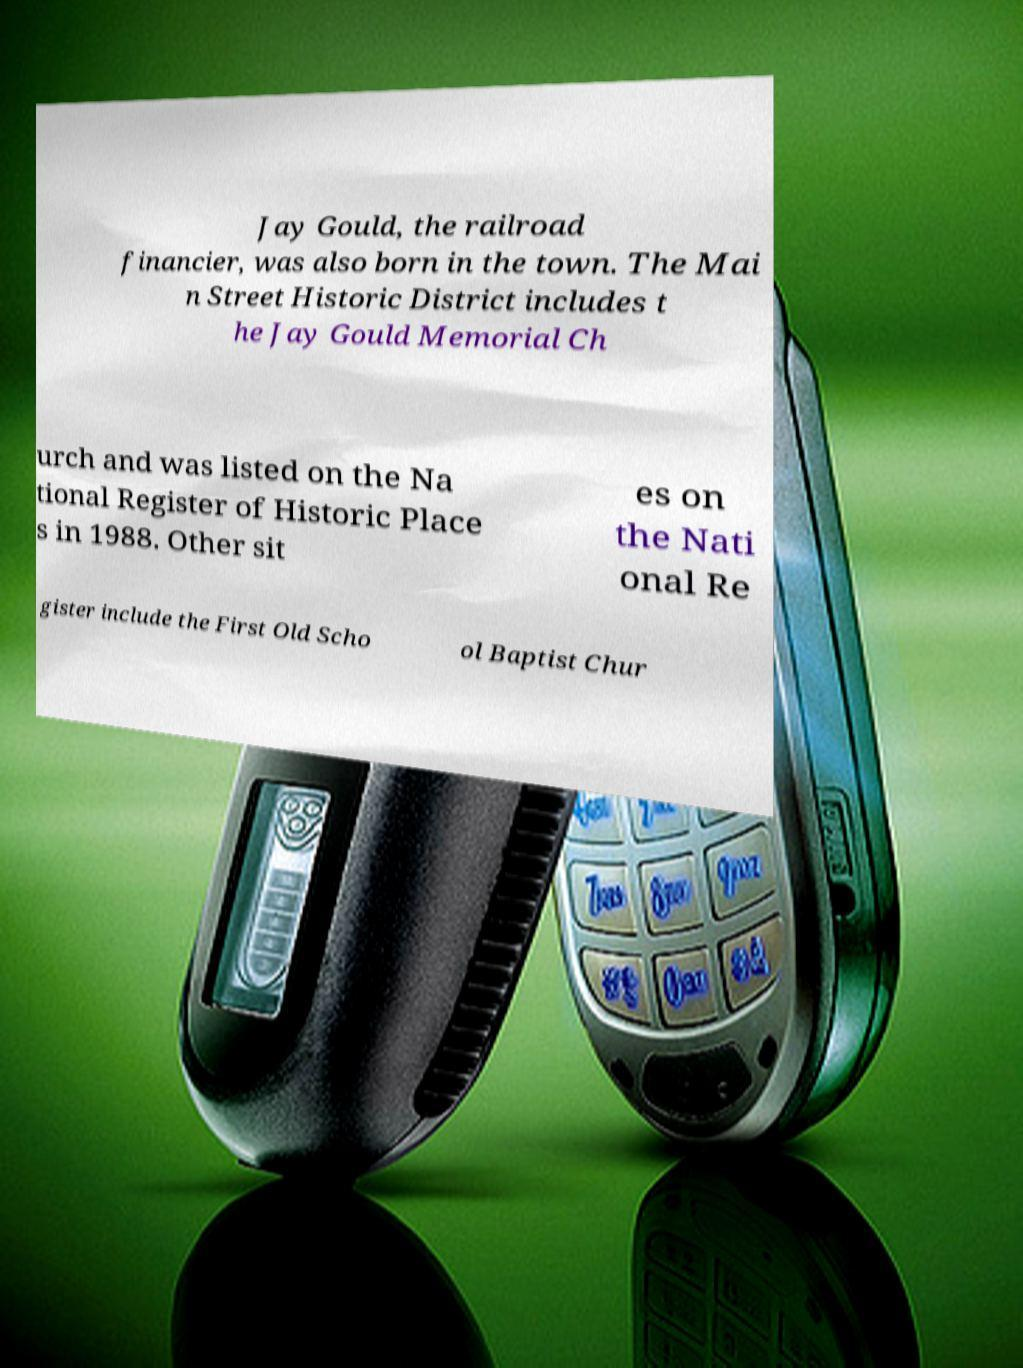I need the written content from this picture converted into text. Can you do that? Jay Gould, the railroad financier, was also born in the town. The Mai n Street Historic District includes t he Jay Gould Memorial Ch urch and was listed on the Na tional Register of Historic Place s in 1988. Other sit es on the Nati onal Re gister include the First Old Scho ol Baptist Chur 